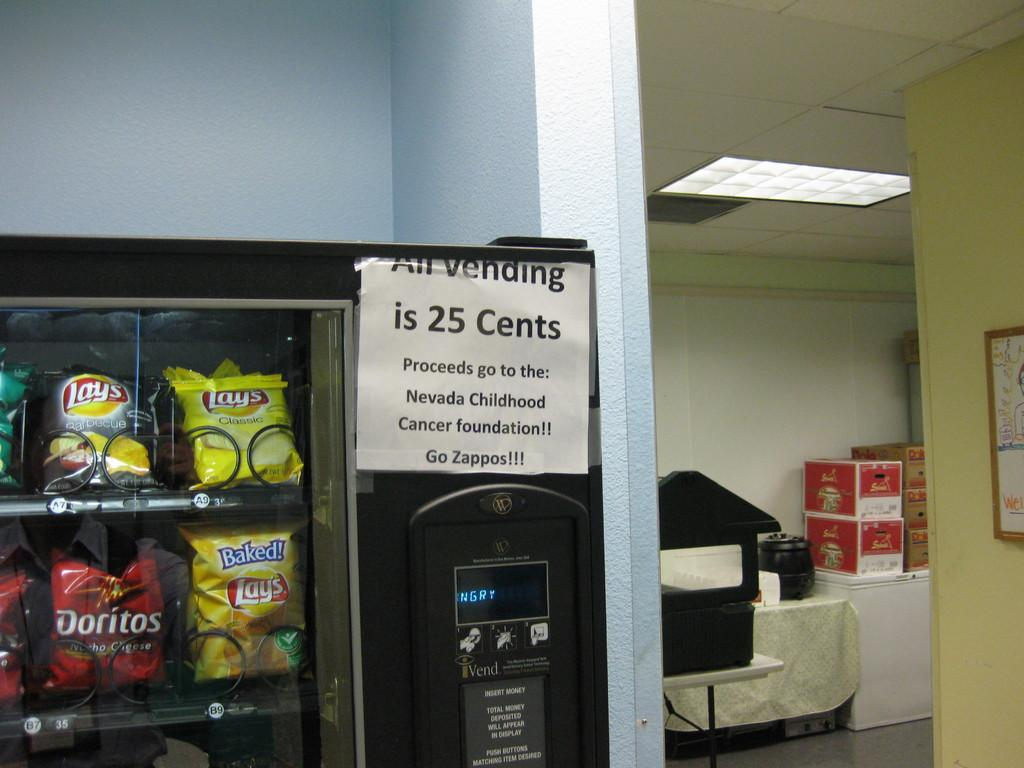Provide a one-sentence caption for the provided image. Vending machine selling potato chips including bags of Doritos. 